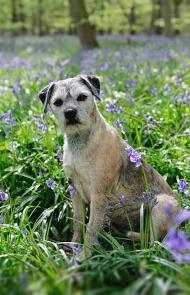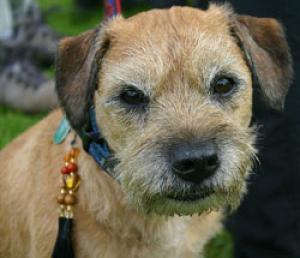The first image is the image on the left, the second image is the image on the right. For the images shown, is this caption "There are purple flowers behind the dog in one of the images but not the other." true? Answer yes or no. Yes. The first image is the image on the left, the second image is the image on the right. Analyze the images presented: Is the assertion "The collar on the dog in the right image, it is clearly visible." valid? Answer yes or no. Yes. 